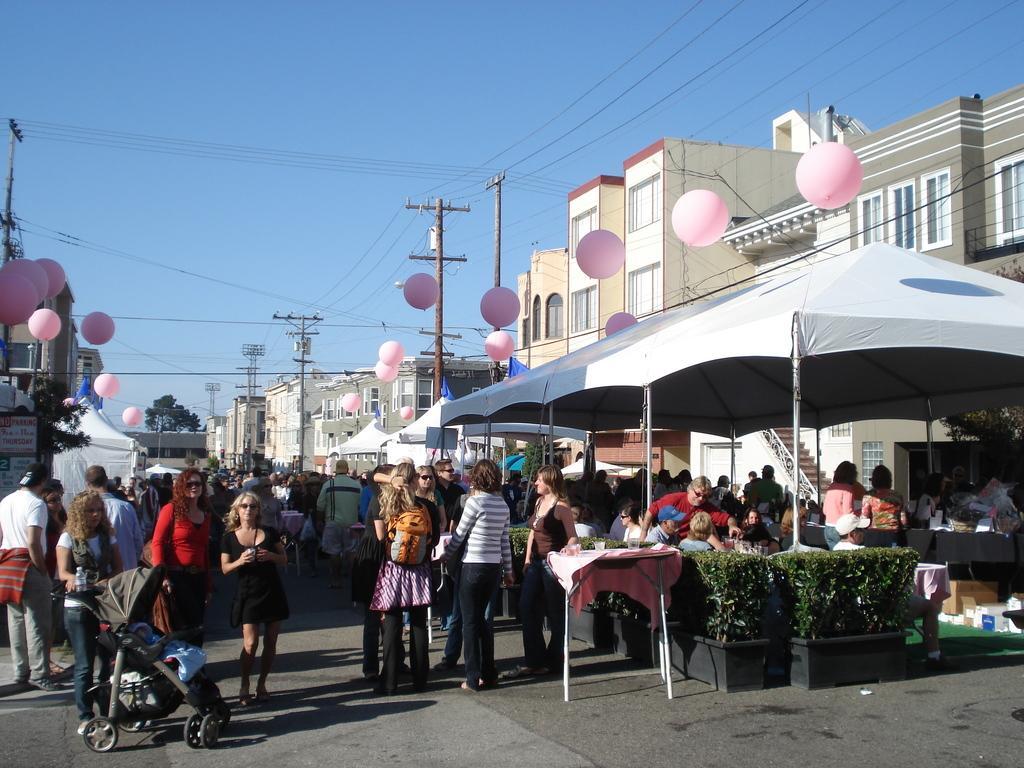Please provide a concise description of this image. In this image there are buildings and poles. We can see wires. At the bottom there are people and we can see a trolley. There are tables and a tent. We can see hedges and there are people sitting. In the background there are balloons and sky. We can see trees. 